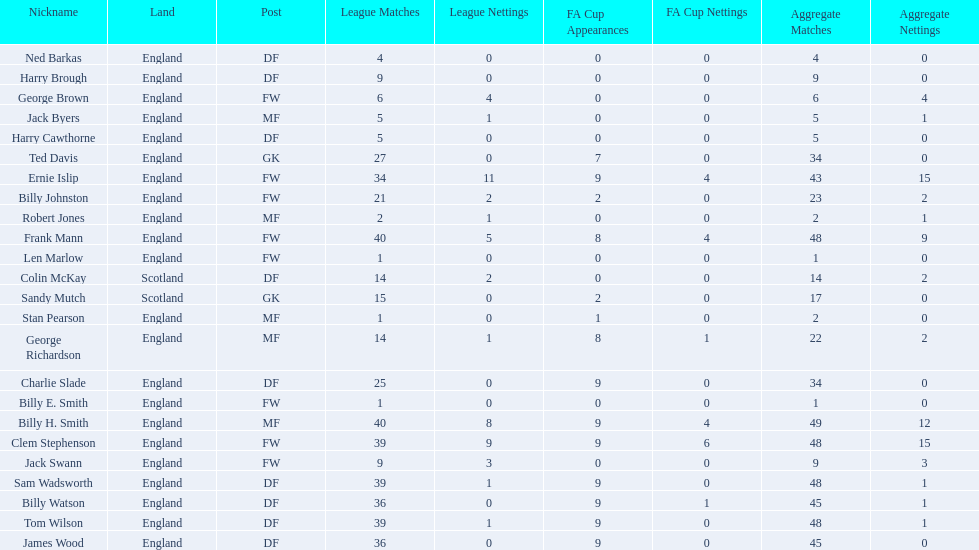Average number of goals scored by players from scotland 1. 